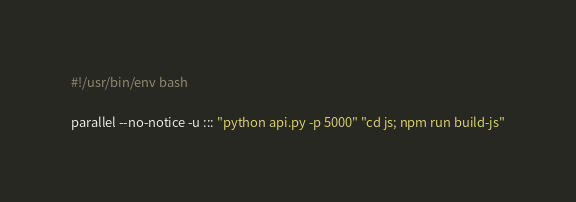<code> <loc_0><loc_0><loc_500><loc_500><_Bash_>#!/usr/bin/env bash

parallel --no-notice -u ::: "python api.py -p 5000" "cd js; npm run build-js"
</code> 